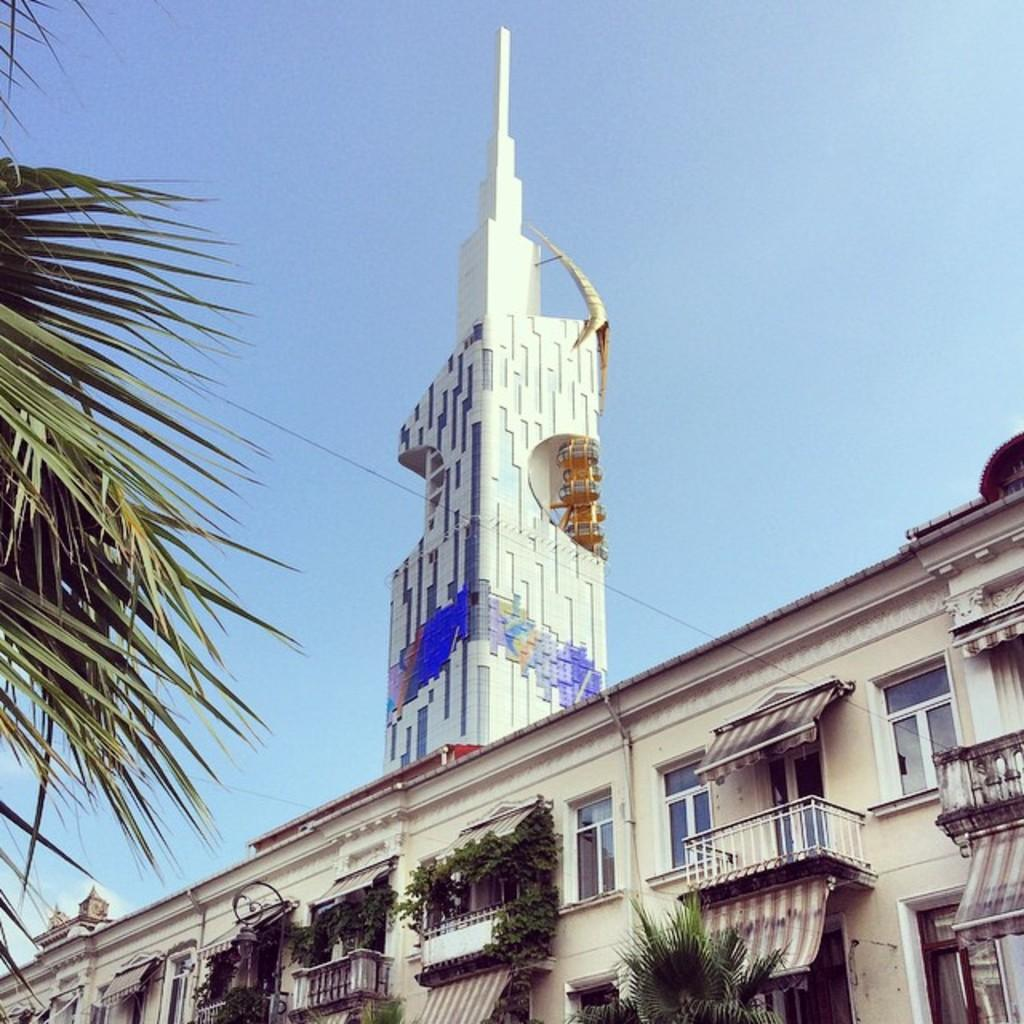What type of structure is present in the image? There is a building in the image. What are some features of the building? The building has walls, glass windows, roofs, balconies, and pillars. What can be seen on the left side of the image? There are tree leaves on the left side of the image. What is visible in the background of the image? The sky is visible in the background of the image. Where is the lunchroom located in the image? There is no mention of a lunchroom in the image; it only features a building with various architectural elements. What color is the silver in the image? There is no silver present in the image. 